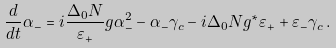<formula> <loc_0><loc_0><loc_500><loc_500>\frac { d } { d t } \alpha _ { - } = i \frac { \Delta _ { 0 } N } { \varepsilon _ { + } } g \alpha _ { - } ^ { 2 } - \alpha _ { - } \gamma _ { c } - i \Delta _ { 0 } N g ^ { * } \varepsilon _ { + } + \varepsilon _ { - } \gamma _ { c } \, .</formula> 